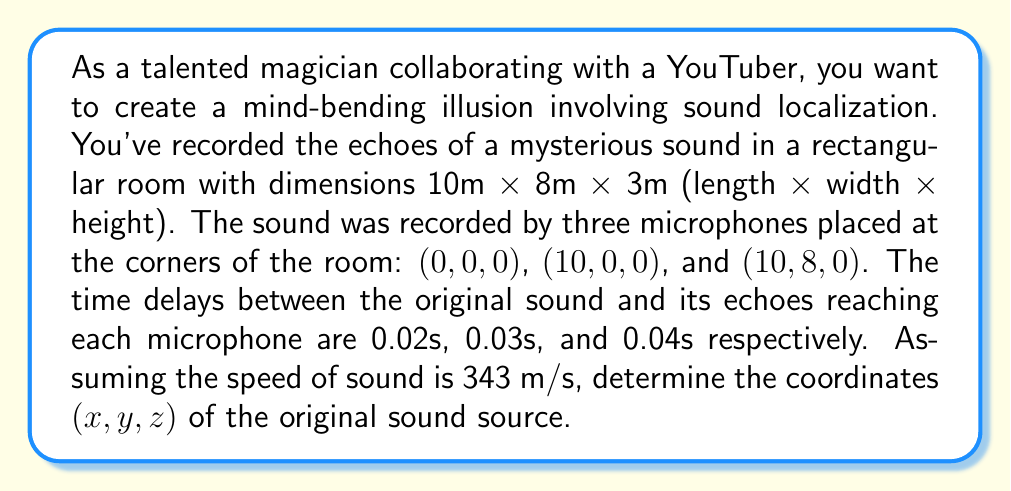What is the answer to this math problem? Let's approach this step-by-step:

1) First, we need to set up equations based on the distances traveled by the sound. The distance is equal to the speed of sound multiplied by the time taken:

   $d = v \times t$

2) For each microphone, we can set up an equation:

   Microphone 1 (0,0,0): $\sqrt{x^2 + y^2 + z^2} = 343 \times 0.02 = 6.86$
   Microphone 2 (10,0,0): $\sqrt{(x-10)^2 + y^2 + z^2} = 343 \times 0.03 = 10.29$
   Microphone 3 (10,8,0): $\sqrt{(x-10)^2 + (y-8)^2 + z^2} = 343 \times 0.04 = 13.72$

3) Square both sides of each equation:

   $x^2 + y^2 + z^2 = 47.0596$
   $(x-10)^2 + y^2 + z^2 = 105.8841$
   $(x-10)^2 + (y-8)^2 + z^2 = 188.2384$

4) Subtract the first equation from the second:

   $x^2 - (x-10)^2 = 47.0596 - 105.8841$
   $x^2 - (x^2 - 20x + 100) = -58.8245$
   $20x - 100 = -58.8245$
   $20x = 41.1755$
   $x = 2.05877$

5) Substitute this x-value into the first equation:

   $(2.05877)^2 + y^2 + z^2 = 47.0596$
   $y^2 + z^2 = 42.8234$

6) Use the third equation:

   $(2.05877-10)^2 + (y-8)^2 + z^2 = 188.2384$
   $62.8234 + (y-8)^2 + z^2 = 188.2384$
   $(y-8)^2 + z^2 = 125.415$

7) Subtract the equation from step 5 from this:

   $(y-8)^2 - y^2 = 125.415 - 42.8234 = 82.5916$
   $y^2 - 16y + 64 - y^2 = 82.5916$
   $-16y = 18.5916$
   $y = 1.1620$

8) Finally, substitute x and y into the equation from step 5:

   $z^2 = 42.8234 - (2.05877)^2 - (1.1620)^2 = 38.2631$
   $z = \sqrt{38.2631} = 6.1858$

Therefore, the coordinates of the sound source are approximately (2.06, 1.16, 6.19).
Answer: $(2.06, 1.16, 6.19)$ 